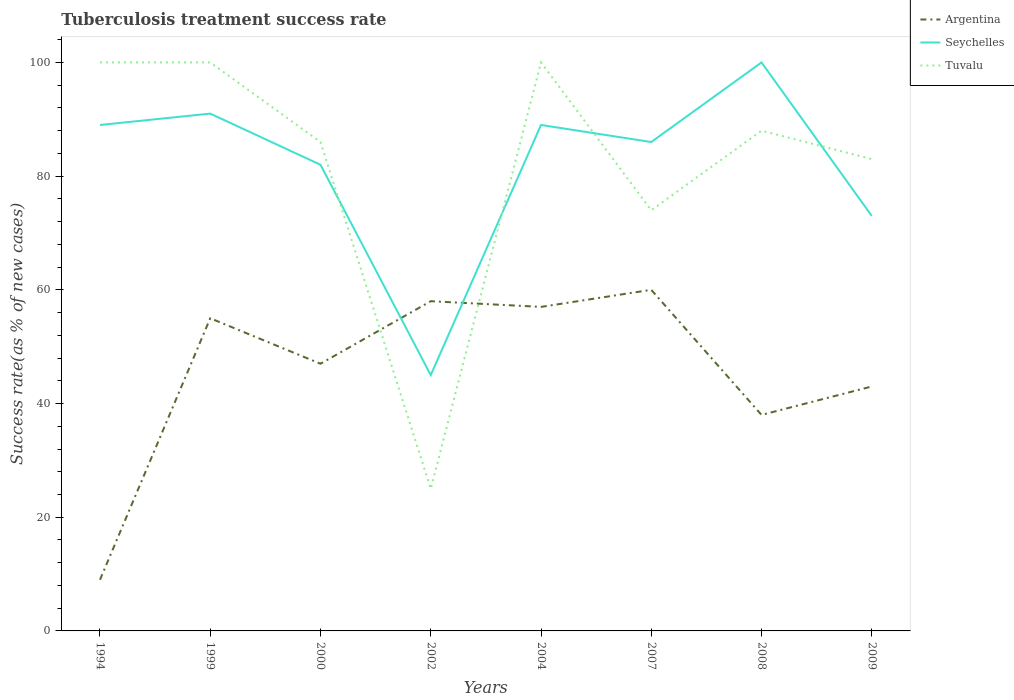Does the line corresponding to Tuvalu intersect with the line corresponding to Argentina?
Keep it short and to the point. Yes. Across all years, what is the maximum tuberculosis treatment success rate in Tuvalu?
Provide a short and direct response. 25. What is the total tuberculosis treatment success rate in Argentina in the graph?
Keep it short and to the point. -48. What is the difference between the highest and the second highest tuberculosis treatment success rate in Tuvalu?
Offer a very short reply. 75. What is the difference between the highest and the lowest tuberculosis treatment success rate in Seychelles?
Provide a short and direct response. 6. Is the tuberculosis treatment success rate in Seychelles strictly greater than the tuberculosis treatment success rate in Argentina over the years?
Offer a very short reply. No. What is the difference between two consecutive major ticks on the Y-axis?
Offer a very short reply. 20. Are the values on the major ticks of Y-axis written in scientific E-notation?
Ensure brevity in your answer.  No. Does the graph contain any zero values?
Your answer should be very brief. No. Does the graph contain grids?
Provide a succinct answer. No. What is the title of the graph?
Make the answer very short. Tuberculosis treatment success rate. Does "Cabo Verde" appear as one of the legend labels in the graph?
Ensure brevity in your answer.  No. What is the label or title of the X-axis?
Your answer should be compact. Years. What is the label or title of the Y-axis?
Provide a short and direct response. Success rate(as % of new cases). What is the Success rate(as % of new cases) in Seychelles in 1994?
Offer a very short reply. 89. What is the Success rate(as % of new cases) of Seychelles in 1999?
Provide a succinct answer. 91. What is the Success rate(as % of new cases) in Argentina in 2000?
Your response must be concise. 47. What is the Success rate(as % of new cases) in Tuvalu in 2000?
Ensure brevity in your answer.  86. What is the Success rate(as % of new cases) of Argentina in 2004?
Provide a short and direct response. 57. What is the Success rate(as % of new cases) of Seychelles in 2004?
Provide a succinct answer. 89. What is the Success rate(as % of new cases) in Tuvalu in 2004?
Your answer should be very brief. 100. What is the Success rate(as % of new cases) in Argentina in 2007?
Give a very brief answer. 60. What is the Success rate(as % of new cases) in Seychelles in 2007?
Offer a terse response. 86. What is the Success rate(as % of new cases) in Tuvalu in 2007?
Your response must be concise. 74. What is the Success rate(as % of new cases) of Argentina in 2008?
Your answer should be very brief. 38. What is the Success rate(as % of new cases) of Tuvalu in 2008?
Make the answer very short. 88. What is the Success rate(as % of new cases) of Seychelles in 2009?
Make the answer very short. 73. Across all years, what is the minimum Success rate(as % of new cases) of Argentina?
Your answer should be very brief. 9. What is the total Success rate(as % of new cases) in Argentina in the graph?
Your answer should be compact. 367. What is the total Success rate(as % of new cases) in Seychelles in the graph?
Give a very brief answer. 655. What is the total Success rate(as % of new cases) in Tuvalu in the graph?
Give a very brief answer. 656. What is the difference between the Success rate(as % of new cases) in Argentina in 1994 and that in 1999?
Provide a short and direct response. -46. What is the difference between the Success rate(as % of new cases) of Seychelles in 1994 and that in 1999?
Your answer should be compact. -2. What is the difference between the Success rate(as % of new cases) in Argentina in 1994 and that in 2000?
Provide a succinct answer. -38. What is the difference between the Success rate(as % of new cases) in Argentina in 1994 and that in 2002?
Offer a terse response. -49. What is the difference between the Success rate(as % of new cases) of Seychelles in 1994 and that in 2002?
Make the answer very short. 44. What is the difference between the Success rate(as % of new cases) in Argentina in 1994 and that in 2004?
Your response must be concise. -48. What is the difference between the Success rate(as % of new cases) of Seychelles in 1994 and that in 2004?
Make the answer very short. 0. What is the difference between the Success rate(as % of new cases) in Tuvalu in 1994 and that in 2004?
Your answer should be compact. 0. What is the difference between the Success rate(as % of new cases) of Argentina in 1994 and that in 2007?
Provide a succinct answer. -51. What is the difference between the Success rate(as % of new cases) in Seychelles in 1994 and that in 2008?
Give a very brief answer. -11. What is the difference between the Success rate(as % of new cases) in Tuvalu in 1994 and that in 2008?
Your response must be concise. 12. What is the difference between the Success rate(as % of new cases) in Argentina in 1994 and that in 2009?
Offer a terse response. -34. What is the difference between the Success rate(as % of new cases) in Seychelles in 1994 and that in 2009?
Provide a short and direct response. 16. What is the difference between the Success rate(as % of new cases) of Argentina in 1999 and that in 2000?
Keep it short and to the point. 8. What is the difference between the Success rate(as % of new cases) in Seychelles in 1999 and that in 2000?
Provide a succinct answer. 9. What is the difference between the Success rate(as % of new cases) of Tuvalu in 1999 and that in 2000?
Ensure brevity in your answer.  14. What is the difference between the Success rate(as % of new cases) in Argentina in 1999 and that in 2002?
Your answer should be very brief. -3. What is the difference between the Success rate(as % of new cases) of Tuvalu in 1999 and that in 2002?
Offer a terse response. 75. What is the difference between the Success rate(as % of new cases) of Argentina in 1999 and that in 2004?
Ensure brevity in your answer.  -2. What is the difference between the Success rate(as % of new cases) in Tuvalu in 1999 and that in 2004?
Your response must be concise. 0. What is the difference between the Success rate(as % of new cases) of Seychelles in 1999 and that in 2007?
Your answer should be very brief. 5. What is the difference between the Success rate(as % of new cases) of Tuvalu in 1999 and that in 2007?
Keep it short and to the point. 26. What is the difference between the Success rate(as % of new cases) of Tuvalu in 1999 and that in 2008?
Offer a very short reply. 12. What is the difference between the Success rate(as % of new cases) of Argentina in 2000 and that in 2002?
Keep it short and to the point. -11. What is the difference between the Success rate(as % of new cases) in Argentina in 2000 and that in 2004?
Ensure brevity in your answer.  -10. What is the difference between the Success rate(as % of new cases) of Seychelles in 2000 and that in 2004?
Make the answer very short. -7. What is the difference between the Success rate(as % of new cases) in Argentina in 2000 and that in 2007?
Make the answer very short. -13. What is the difference between the Success rate(as % of new cases) of Seychelles in 2000 and that in 2007?
Your response must be concise. -4. What is the difference between the Success rate(as % of new cases) of Tuvalu in 2000 and that in 2007?
Offer a very short reply. 12. What is the difference between the Success rate(as % of new cases) of Argentina in 2000 and that in 2008?
Keep it short and to the point. 9. What is the difference between the Success rate(as % of new cases) in Seychelles in 2000 and that in 2008?
Your answer should be very brief. -18. What is the difference between the Success rate(as % of new cases) of Tuvalu in 2000 and that in 2008?
Your response must be concise. -2. What is the difference between the Success rate(as % of new cases) of Argentina in 2002 and that in 2004?
Give a very brief answer. 1. What is the difference between the Success rate(as % of new cases) in Seychelles in 2002 and that in 2004?
Your answer should be very brief. -44. What is the difference between the Success rate(as % of new cases) in Tuvalu in 2002 and that in 2004?
Offer a terse response. -75. What is the difference between the Success rate(as % of new cases) in Seychelles in 2002 and that in 2007?
Your response must be concise. -41. What is the difference between the Success rate(as % of new cases) of Tuvalu in 2002 and that in 2007?
Provide a succinct answer. -49. What is the difference between the Success rate(as % of new cases) in Argentina in 2002 and that in 2008?
Your answer should be compact. 20. What is the difference between the Success rate(as % of new cases) of Seychelles in 2002 and that in 2008?
Your answer should be very brief. -55. What is the difference between the Success rate(as % of new cases) in Tuvalu in 2002 and that in 2008?
Ensure brevity in your answer.  -63. What is the difference between the Success rate(as % of new cases) in Argentina in 2002 and that in 2009?
Your answer should be compact. 15. What is the difference between the Success rate(as % of new cases) of Seychelles in 2002 and that in 2009?
Ensure brevity in your answer.  -28. What is the difference between the Success rate(as % of new cases) of Tuvalu in 2002 and that in 2009?
Ensure brevity in your answer.  -58. What is the difference between the Success rate(as % of new cases) of Argentina in 2004 and that in 2007?
Your answer should be very brief. -3. What is the difference between the Success rate(as % of new cases) of Tuvalu in 2004 and that in 2007?
Provide a short and direct response. 26. What is the difference between the Success rate(as % of new cases) of Seychelles in 2004 and that in 2008?
Provide a short and direct response. -11. What is the difference between the Success rate(as % of new cases) of Tuvalu in 2004 and that in 2008?
Your answer should be compact. 12. What is the difference between the Success rate(as % of new cases) of Argentina in 2007 and that in 2009?
Your answer should be very brief. 17. What is the difference between the Success rate(as % of new cases) of Seychelles in 2007 and that in 2009?
Offer a terse response. 13. What is the difference between the Success rate(as % of new cases) in Argentina in 2008 and that in 2009?
Give a very brief answer. -5. What is the difference between the Success rate(as % of new cases) of Seychelles in 2008 and that in 2009?
Ensure brevity in your answer.  27. What is the difference between the Success rate(as % of new cases) in Argentina in 1994 and the Success rate(as % of new cases) in Seychelles in 1999?
Provide a succinct answer. -82. What is the difference between the Success rate(as % of new cases) of Argentina in 1994 and the Success rate(as % of new cases) of Tuvalu in 1999?
Make the answer very short. -91. What is the difference between the Success rate(as % of new cases) of Seychelles in 1994 and the Success rate(as % of new cases) of Tuvalu in 1999?
Your response must be concise. -11. What is the difference between the Success rate(as % of new cases) in Argentina in 1994 and the Success rate(as % of new cases) in Seychelles in 2000?
Give a very brief answer. -73. What is the difference between the Success rate(as % of new cases) of Argentina in 1994 and the Success rate(as % of new cases) of Tuvalu in 2000?
Give a very brief answer. -77. What is the difference between the Success rate(as % of new cases) in Seychelles in 1994 and the Success rate(as % of new cases) in Tuvalu in 2000?
Your answer should be compact. 3. What is the difference between the Success rate(as % of new cases) in Argentina in 1994 and the Success rate(as % of new cases) in Seychelles in 2002?
Your response must be concise. -36. What is the difference between the Success rate(as % of new cases) in Seychelles in 1994 and the Success rate(as % of new cases) in Tuvalu in 2002?
Offer a terse response. 64. What is the difference between the Success rate(as % of new cases) of Argentina in 1994 and the Success rate(as % of new cases) of Seychelles in 2004?
Provide a succinct answer. -80. What is the difference between the Success rate(as % of new cases) in Argentina in 1994 and the Success rate(as % of new cases) in Tuvalu in 2004?
Give a very brief answer. -91. What is the difference between the Success rate(as % of new cases) of Argentina in 1994 and the Success rate(as % of new cases) of Seychelles in 2007?
Keep it short and to the point. -77. What is the difference between the Success rate(as % of new cases) in Argentina in 1994 and the Success rate(as % of new cases) in Tuvalu in 2007?
Give a very brief answer. -65. What is the difference between the Success rate(as % of new cases) in Seychelles in 1994 and the Success rate(as % of new cases) in Tuvalu in 2007?
Give a very brief answer. 15. What is the difference between the Success rate(as % of new cases) in Argentina in 1994 and the Success rate(as % of new cases) in Seychelles in 2008?
Ensure brevity in your answer.  -91. What is the difference between the Success rate(as % of new cases) of Argentina in 1994 and the Success rate(as % of new cases) of Tuvalu in 2008?
Ensure brevity in your answer.  -79. What is the difference between the Success rate(as % of new cases) of Seychelles in 1994 and the Success rate(as % of new cases) of Tuvalu in 2008?
Provide a succinct answer. 1. What is the difference between the Success rate(as % of new cases) of Argentina in 1994 and the Success rate(as % of new cases) of Seychelles in 2009?
Offer a very short reply. -64. What is the difference between the Success rate(as % of new cases) of Argentina in 1994 and the Success rate(as % of new cases) of Tuvalu in 2009?
Provide a short and direct response. -74. What is the difference between the Success rate(as % of new cases) of Argentina in 1999 and the Success rate(as % of new cases) of Tuvalu in 2000?
Ensure brevity in your answer.  -31. What is the difference between the Success rate(as % of new cases) of Argentina in 1999 and the Success rate(as % of new cases) of Seychelles in 2002?
Your answer should be very brief. 10. What is the difference between the Success rate(as % of new cases) of Seychelles in 1999 and the Success rate(as % of new cases) of Tuvalu in 2002?
Your answer should be compact. 66. What is the difference between the Success rate(as % of new cases) of Argentina in 1999 and the Success rate(as % of new cases) of Seychelles in 2004?
Offer a terse response. -34. What is the difference between the Success rate(as % of new cases) of Argentina in 1999 and the Success rate(as % of new cases) of Tuvalu in 2004?
Provide a short and direct response. -45. What is the difference between the Success rate(as % of new cases) in Argentina in 1999 and the Success rate(as % of new cases) in Seychelles in 2007?
Your response must be concise. -31. What is the difference between the Success rate(as % of new cases) in Argentina in 1999 and the Success rate(as % of new cases) in Tuvalu in 2007?
Make the answer very short. -19. What is the difference between the Success rate(as % of new cases) in Seychelles in 1999 and the Success rate(as % of new cases) in Tuvalu in 2007?
Give a very brief answer. 17. What is the difference between the Success rate(as % of new cases) of Argentina in 1999 and the Success rate(as % of new cases) of Seychelles in 2008?
Keep it short and to the point. -45. What is the difference between the Success rate(as % of new cases) of Argentina in 1999 and the Success rate(as % of new cases) of Tuvalu in 2008?
Make the answer very short. -33. What is the difference between the Success rate(as % of new cases) of Argentina in 1999 and the Success rate(as % of new cases) of Seychelles in 2009?
Give a very brief answer. -18. What is the difference between the Success rate(as % of new cases) of Seychelles in 1999 and the Success rate(as % of new cases) of Tuvalu in 2009?
Make the answer very short. 8. What is the difference between the Success rate(as % of new cases) in Argentina in 2000 and the Success rate(as % of new cases) in Seychelles in 2004?
Offer a very short reply. -42. What is the difference between the Success rate(as % of new cases) of Argentina in 2000 and the Success rate(as % of new cases) of Tuvalu in 2004?
Provide a short and direct response. -53. What is the difference between the Success rate(as % of new cases) in Argentina in 2000 and the Success rate(as % of new cases) in Seychelles in 2007?
Your response must be concise. -39. What is the difference between the Success rate(as % of new cases) in Argentina in 2000 and the Success rate(as % of new cases) in Tuvalu in 2007?
Provide a succinct answer. -27. What is the difference between the Success rate(as % of new cases) of Argentina in 2000 and the Success rate(as % of new cases) of Seychelles in 2008?
Provide a short and direct response. -53. What is the difference between the Success rate(as % of new cases) of Argentina in 2000 and the Success rate(as % of new cases) of Tuvalu in 2008?
Give a very brief answer. -41. What is the difference between the Success rate(as % of new cases) of Argentina in 2000 and the Success rate(as % of new cases) of Tuvalu in 2009?
Keep it short and to the point. -36. What is the difference between the Success rate(as % of new cases) of Seychelles in 2000 and the Success rate(as % of new cases) of Tuvalu in 2009?
Make the answer very short. -1. What is the difference between the Success rate(as % of new cases) of Argentina in 2002 and the Success rate(as % of new cases) of Seychelles in 2004?
Offer a terse response. -31. What is the difference between the Success rate(as % of new cases) of Argentina in 2002 and the Success rate(as % of new cases) of Tuvalu in 2004?
Provide a short and direct response. -42. What is the difference between the Success rate(as % of new cases) of Seychelles in 2002 and the Success rate(as % of new cases) of Tuvalu in 2004?
Offer a very short reply. -55. What is the difference between the Success rate(as % of new cases) of Argentina in 2002 and the Success rate(as % of new cases) of Seychelles in 2008?
Offer a terse response. -42. What is the difference between the Success rate(as % of new cases) of Seychelles in 2002 and the Success rate(as % of new cases) of Tuvalu in 2008?
Offer a terse response. -43. What is the difference between the Success rate(as % of new cases) of Argentina in 2002 and the Success rate(as % of new cases) of Seychelles in 2009?
Give a very brief answer. -15. What is the difference between the Success rate(as % of new cases) in Seychelles in 2002 and the Success rate(as % of new cases) in Tuvalu in 2009?
Your answer should be compact. -38. What is the difference between the Success rate(as % of new cases) of Argentina in 2004 and the Success rate(as % of new cases) of Seychelles in 2007?
Your answer should be very brief. -29. What is the difference between the Success rate(as % of new cases) in Argentina in 2004 and the Success rate(as % of new cases) in Seychelles in 2008?
Offer a terse response. -43. What is the difference between the Success rate(as % of new cases) of Argentina in 2004 and the Success rate(as % of new cases) of Tuvalu in 2008?
Your answer should be very brief. -31. What is the difference between the Success rate(as % of new cases) in Seychelles in 2004 and the Success rate(as % of new cases) in Tuvalu in 2008?
Offer a very short reply. 1. What is the difference between the Success rate(as % of new cases) of Argentina in 2007 and the Success rate(as % of new cases) of Tuvalu in 2008?
Offer a terse response. -28. What is the difference between the Success rate(as % of new cases) of Argentina in 2007 and the Success rate(as % of new cases) of Seychelles in 2009?
Provide a succinct answer. -13. What is the difference between the Success rate(as % of new cases) in Argentina in 2007 and the Success rate(as % of new cases) in Tuvalu in 2009?
Give a very brief answer. -23. What is the difference between the Success rate(as % of new cases) in Argentina in 2008 and the Success rate(as % of new cases) in Seychelles in 2009?
Keep it short and to the point. -35. What is the difference between the Success rate(as % of new cases) of Argentina in 2008 and the Success rate(as % of new cases) of Tuvalu in 2009?
Your answer should be very brief. -45. What is the average Success rate(as % of new cases) in Argentina per year?
Your answer should be very brief. 45.88. What is the average Success rate(as % of new cases) of Seychelles per year?
Your response must be concise. 81.88. In the year 1994, what is the difference between the Success rate(as % of new cases) of Argentina and Success rate(as % of new cases) of Seychelles?
Offer a very short reply. -80. In the year 1994, what is the difference between the Success rate(as % of new cases) in Argentina and Success rate(as % of new cases) in Tuvalu?
Provide a short and direct response. -91. In the year 1999, what is the difference between the Success rate(as % of new cases) of Argentina and Success rate(as % of new cases) of Seychelles?
Ensure brevity in your answer.  -36. In the year 1999, what is the difference between the Success rate(as % of new cases) of Argentina and Success rate(as % of new cases) of Tuvalu?
Make the answer very short. -45. In the year 1999, what is the difference between the Success rate(as % of new cases) of Seychelles and Success rate(as % of new cases) of Tuvalu?
Your answer should be compact. -9. In the year 2000, what is the difference between the Success rate(as % of new cases) in Argentina and Success rate(as % of new cases) in Seychelles?
Your answer should be compact. -35. In the year 2000, what is the difference between the Success rate(as % of new cases) of Argentina and Success rate(as % of new cases) of Tuvalu?
Provide a succinct answer. -39. In the year 2002, what is the difference between the Success rate(as % of new cases) in Argentina and Success rate(as % of new cases) in Seychelles?
Provide a succinct answer. 13. In the year 2002, what is the difference between the Success rate(as % of new cases) in Argentina and Success rate(as % of new cases) in Tuvalu?
Provide a short and direct response. 33. In the year 2004, what is the difference between the Success rate(as % of new cases) of Argentina and Success rate(as % of new cases) of Seychelles?
Make the answer very short. -32. In the year 2004, what is the difference between the Success rate(as % of new cases) of Argentina and Success rate(as % of new cases) of Tuvalu?
Give a very brief answer. -43. In the year 2004, what is the difference between the Success rate(as % of new cases) in Seychelles and Success rate(as % of new cases) in Tuvalu?
Provide a short and direct response. -11. In the year 2007, what is the difference between the Success rate(as % of new cases) of Seychelles and Success rate(as % of new cases) of Tuvalu?
Ensure brevity in your answer.  12. In the year 2008, what is the difference between the Success rate(as % of new cases) of Argentina and Success rate(as % of new cases) of Seychelles?
Your response must be concise. -62. In the year 2009, what is the difference between the Success rate(as % of new cases) of Argentina and Success rate(as % of new cases) of Tuvalu?
Your answer should be very brief. -40. In the year 2009, what is the difference between the Success rate(as % of new cases) of Seychelles and Success rate(as % of new cases) of Tuvalu?
Ensure brevity in your answer.  -10. What is the ratio of the Success rate(as % of new cases) in Argentina in 1994 to that in 1999?
Offer a very short reply. 0.16. What is the ratio of the Success rate(as % of new cases) in Argentina in 1994 to that in 2000?
Keep it short and to the point. 0.19. What is the ratio of the Success rate(as % of new cases) of Seychelles in 1994 to that in 2000?
Offer a very short reply. 1.09. What is the ratio of the Success rate(as % of new cases) in Tuvalu in 1994 to that in 2000?
Your answer should be compact. 1.16. What is the ratio of the Success rate(as % of new cases) in Argentina in 1994 to that in 2002?
Give a very brief answer. 0.16. What is the ratio of the Success rate(as % of new cases) of Seychelles in 1994 to that in 2002?
Make the answer very short. 1.98. What is the ratio of the Success rate(as % of new cases) in Tuvalu in 1994 to that in 2002?
Your response must be concise. 4. What is the ratio of the Success rate(as % of new cases) of Argentina in 1994 to that in 2004?
Offer a very short reply. 0.16. What is the ratio of the Success rate(as % of new cases) in Seychelles in 1994 to that in 2004?
Your response must be concise. 1. What is the ratio of the Success rate(as % of new cases) of Tuvalu in 1994 to that in 2004?
Give a very brief answer. 1. What is the ratio of the Success rate(as % of new cases) in Argentina in 1994 to that in 2007?
Provide a short and direct response. 0.15. What is the ratio of the Success rate(as % of new cases) of Seychelles in 1994 to that in 2007?
Your response must be concise. 1.03. What is the ratio of the Success rate(as % of new cases) of Tuvalu in 1994 to that in 2007?
Ensure brevity in your answer.  1.35. What is the ratio of the Success rate(as % of new cases) in Argentina in 1994 to that in 2008?
Give a very brief answer. 0.24. What is the ratio of the Success rate(as % of new cases) in Seychelles in 1994 to that in 2008?
Provide a short and direct response. 0.89. What is the ratio of the Success rate(as % of new cases) in Tuvalu in 1994 to that in 2008?
Keep it short and to the point. 1.14. What is the ratio of the Success rate(as % of new cases) in Argentina in 1994 to that in 2009?
Make the answer very short. 0.21. What is the ratio of the Success rate(as % of new cases) of Seychelles in 1994 to that in 2009?
Your answer should be compact. 1.22. What is the ratio of the Success rate(as % of new cases) in Tuvalu in 1994 to that in 2009?
Keep it short and to the point. 1.2. What is the ratio of the Success rate(as % of new cases) in Argentina in 1999 to that in 2000?
Your response must be concise. 1.17. What is the ratio of the Success rate(as % of new cases) of Seychelles in 1999 to that in 2000?
Offer a terse response. 1.11. What is the ratio of the Success rate(as % of new cases) of Tuvalu in 1999 to that in 2000?
Ensure brevity in your answer.  1.16. What is the ratio of the Success rate(as % of new cases) in Argentina in 1999 to that in 2002?
Make the answer very short. 0.95. What is the ratio of the Success rate(as % of new cases) of Seychelles in 1999 to that in 2002?
Your answer should be very brief. 2.02. What is the ratio of the Success rate(as % of new cases) of Tuvalu in 1999 to that in 2002?
Make the answer very short. 4. What is the ratio of the Success rate(as % of new cases) of Argentina in 1999 to that in 2004?
Offer a very short reply. 0.96. What is the ratio of the Success rate(as % of new cases) of Seychelles in 1999 to that in 2004?
Provide a short and direct response. 1.02. What is the ratio of the Success rate(as % of new cases) in Argentina in 1999 to that in 2007?
Provide a succinct answer. 0.92. What is the ratio of the Success rate(as % of new cases) in Seychelles in 1999 to that in 2007?
Your answer should be compact. 1.06. What is the ratio of the Success rate(as % of new cases) in Tuvalu in 1999 to that in 2007?
Provide a short and direct response. 1.35. What is the ratio of the Success rate(as % of new cases) in Argentina in 1999 to that in 2008?
Provide a short and direct response. 1.45. What is the ratio of the Success rate(as % of new cases) in Seychelles in 1999 to that in 2008?
Keep it short and to the point. 0.91. What is the ratio of the Success rate(as % of new cases) in Tuvalu in 1999 to that in 2008?
Keep it short and to the point. 1.14. What is the ratio of the Success rate(as % of new cases) of Argentina in 1999 to that in 2009?
Keep it short and to the point. 1.28. What is the ratio of the Success rate(as % of new cases) of Seychelles in 1999 to that in 2009?
Make the answer very short. 1.25. What is the ratio of the Success rate(as % of new cases) in Tuvalu in 1999 to that in 2009?
Ensure brevity in your answer.  1.2. What is the ratio of the Success rate(as % of new cases) of Argentina in 2000 to that in 2002?
Your response must be concise. 0.81. What is the ratio of the Success rate(as % of new cases) of Seychelles in 2000 to that in 2002?
Your answer should be very brief. 1.82. What is the ratio of the Success rate(as % of new cases) in Tuvalu in 2000 to that in 2002?
Provide a short and direct response. 3.44. What is the ratio of the Success rate(as % of new cases) in Argentina in 2000 to that in 2004?
Give a very brief answer. 0.82. What is the ratio of the Success rate(as % of new cases) of Seychelles in 2000 to that in 2004?
Provide a succinct answer. 0.92. What is the ratio of the Success rate(as % of new cases) in Tuvalu in 2000 to that in 2004?
Keep it short and to the point. 0.86. What is the ratio of the Success rate(as % of new cases) in Argentina in 2000 to that in 2007?
Give a very brief answer. 0.78. What is the ratio of the Success rate(as % of new cases) of Seychelles in 2000 to that in 2007?
Keep it short and to the point. 0.95. What is the ratio of the Success rate(as % of new cases) of Tuvalu in 2000 to that in 2007?
Your answer should be very brief. 1.16. What is the ratio of the Success rate(as % of new cases) of Argentina in 2000 to that in 2008?
Offer a terse response. 1.24. What is the ratio of the Success rate(as % of new cases) of Seychelles in 2000 to that in 2008?
Your answer should be compact. 0.82. What is the ratio of the Success rate(as % of new cases) of Tuvalu in 2000 to that in 2008?
Keep it short and to the point. 0.98. What is the ratio of the Success rate(as % of new cases) in Argentina in 2000 to that in 2009?
Make the answer very short. 1.09. What is the ratio of the Success rate(as % of new cases) of Seychelles in 2000 to that in 2009?
Your answer should be compact. 1.12. What is the ratio of the Success rate(as % of new cases) of Tuvalu in 2000 to that in 2009?
Provide a succinct answer. 1.04. What is the ratio of the Success rate(as % of new cases) in Argentina in 2002 to that in 2004?
Offer a very short reply. 1.02. What is the ratio of the Success rate(as % of new cases) of Seychelles in 2002 to that in 2004?
Your response must be concise. 0.51. What is the ratio of the Success rate(as % of new cases) of Argentina in 2002 to that in 2007?
Your answer should be very brief. 0.97. What is the ratio of the Success rate(as % of new cases) of Seychelles in 2002 to that in 2007?
Make the answer very short. 0.52. What is the ratio of the Success rate(as % of new cases) of Tuvalu in 2002 to that in 2007?
Provide a short and direct response. 0.34. What is the ratio of the Success rate(as % of new cases) in Argentina in 2002 to that in 2008?
Offer a terse response. 1.53. What is the ratio of the Success rate(as % of new cases) in Seychelles in 2002 to that in 2008?
Your answer should be very brief. 0.45. What is the ratio of the Success rate(as % of new cases) in Tuvalu in 2002 to that in 2008?
Your answer should be very brief. 0.28. What is the ratio of the Success rate(as % of new cases) of Argentina in 2002 to that in 2009?
Offer a very short reply. 1.35. What is the ratio of the Success rate(as % of new cases) of Seychelles in 2002 to that in 2009?
Your answer should be very brief. 0.62. What is the ratio of the Success rate(as % of new cases) of Tuvalu in 2002 to that in 2009?
Provide a short and direct response. 0.3. What is the ratio of the Success rate(as % of new cases) in Argentina in 2004 to that in 2007?
Offer a very short reply. 0.95. What is the ratio of the Success rate(as % of new cases) of Seychelles in 2004 to that in 2007?
Your answer should be compact. 1.03. What is the ratio of the Success rate(as % of new cases) in Tuvalu in 2004 to that in 2007?
Provide a short and direct response. 1.35. What is the ratio of the Success rate(as % of new cases) in Argentina in 2004 to that in 2008?
Provide a succinct answer. 1.5. What is the ratio of the Success rate(as % of new cases) in Seychelles in 2004 to that in 2008?
Make the answer very short. 0.89. What is the ratio of the Success rate(as % of new cases) of Tuvalu in 2004 to that in 2008?
Provide a succinct answer. 1.14. What is the ratio of the Success rate(as % of new cases) of Argentina in 2004 to that in 2009?
Provide a short and direct response. 1.33. What is the ratio of the Success rate(as % of new cases) in Seychelles in 2004 to that in 2009?
Your answer should be compact. 1.22. What is the ratio of the Success rate(as % of new cases) of Tuvalu in 2004 to that in 2009?
Provide a short and direct response. 1.2. What is the ratio of the Success rate(as % of new cases) in Argentina in 2007 to that in 2008?
Ensure brevity in your answer.  1.58. What is the ratio of the Success rate(as % of new cases) of Seychelles in 2007 to that in 2008?
Give a very brief answer. 0.86. What is the ratio of the Success rate(as % of new cases) of Tuvalu in 2007 to that in 2008?
Ensure brevity in your answer.  0.84. What is the ratio of the Success rate(as % of new cases) of Argentina in 2007 to that in 2009?
Offer a terse response. 1.4. What is the ratio of the Success rate(as % of new cases) in Seychelles in 2007 to that in 2009?
Keep it short and to the point. 1.18. What is the ratio of the Success rate(as % of new cases) in Tuvalu in 2007 to that in 2009?
Keep it short and to the point. 0.89. What is the ratio of the Success rate(as % of new cases) in Argentina in 2008 to that in 2009?
Your response must be concise. 0.88. What is the ratio of the Success rate(as % of new cases) in Seychelles in 2008 to that in 2009?
Make the answer very short. 1.37. What is the ratio of the Success rate(as % of new cases) of Tuvalu in 2008 to that in 2009?
Ensure brevity in your answer.  1.06. What is the difference between the highest and the second highest Success rate(as % of new cases) in Argentina?
Keep it short and to the point. 2. What is the difference between the highest and the second highest Success rate(as % of new cases) of Seychelles?
Provide a short and direct response. 9. What is the difference between the highest and the second highest Success rate(as % of new cases) of Tuvalu?
Your answer should be compact. 0. 